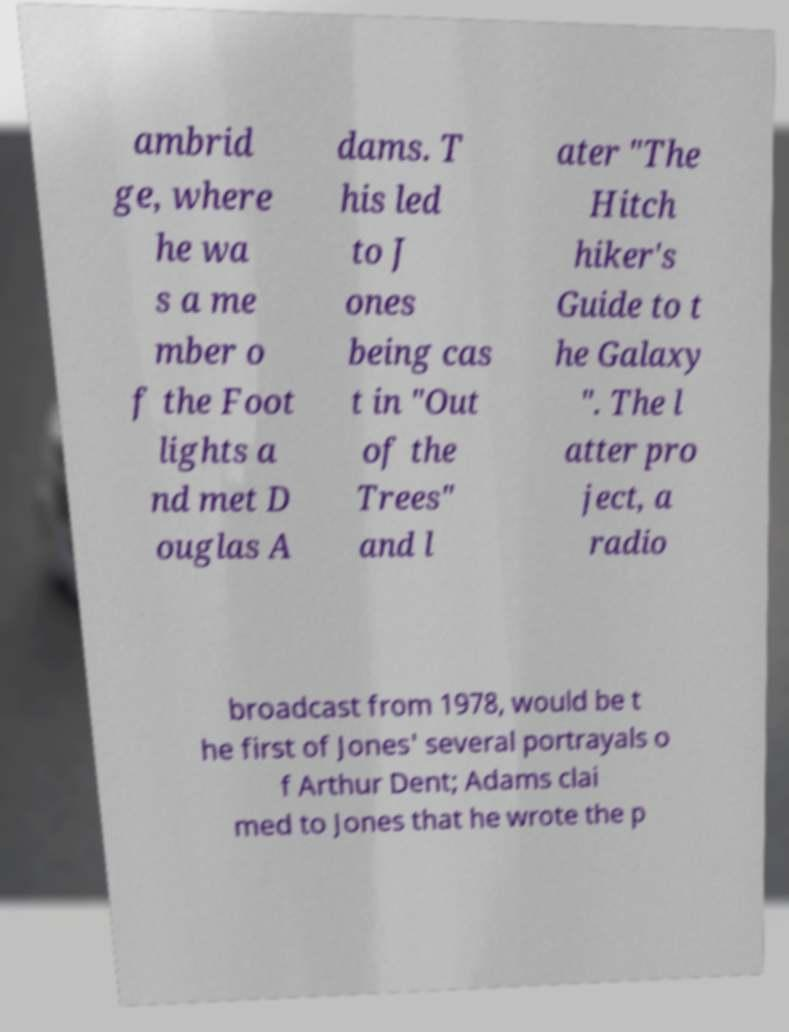I need the written content from this picture converted into text. Can you do that? ambrid ge, where he wa s a me mber o f the Foot lights a nd met D ouglas A dams. T his led to J ones being cas t in "Out of the Trees" and l ater "The Hitch hiker's Guide to t he Galaxy ". The l atter pro ject, a radio broadcast from 1978, would be t he first of Jones' several portrayals o f Arthur Dent; Adams clai med to Jones that he wrote the p 